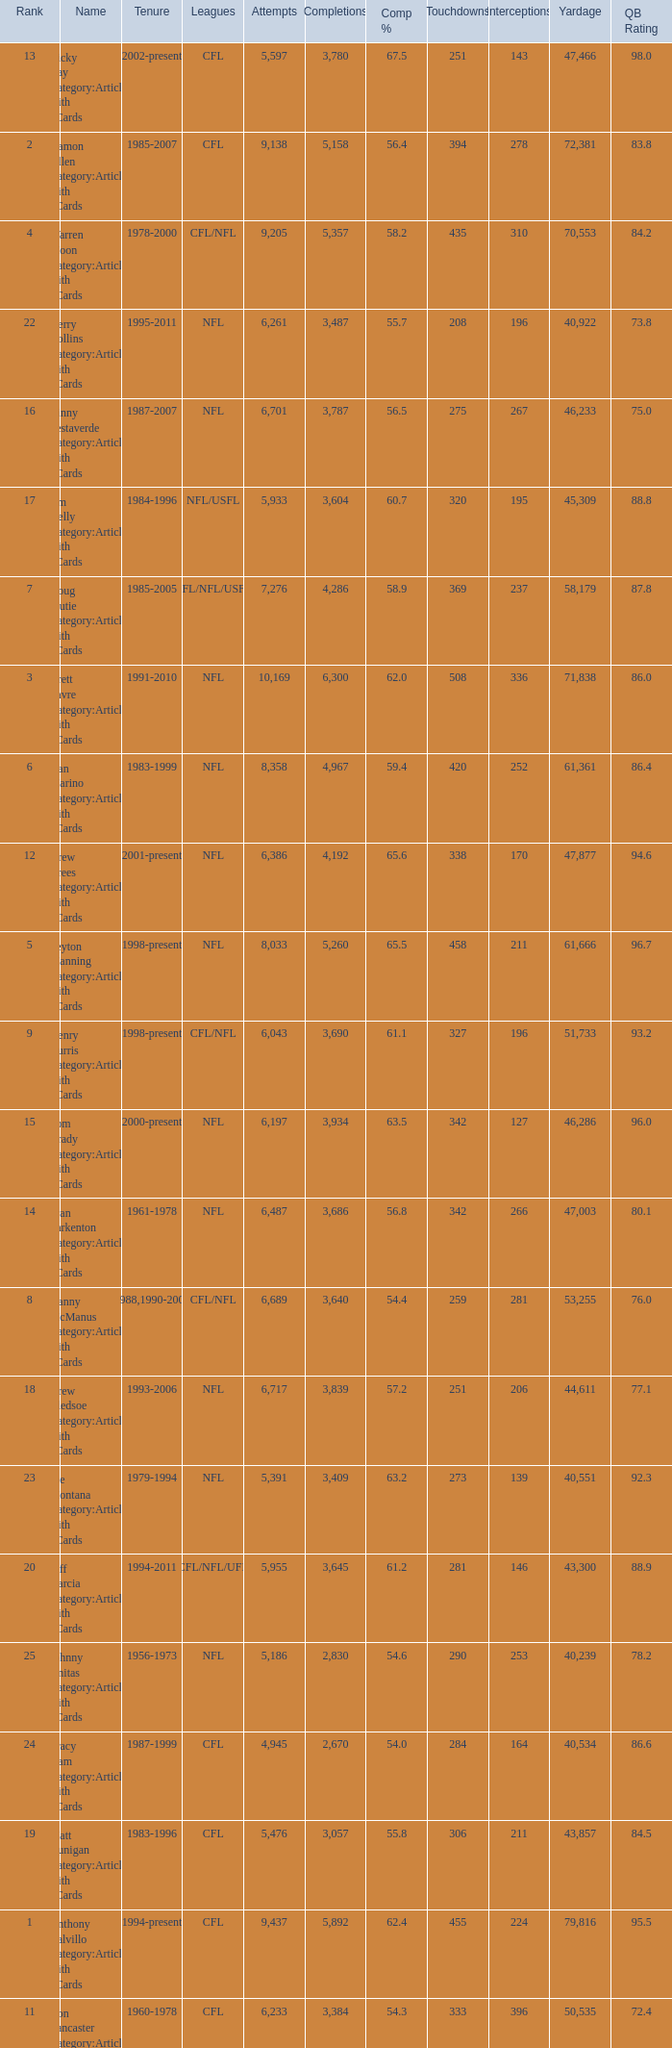What is the number of interceptions with less than 3,487 completions , more than 40,551 yardage, and the comp % is 55.8? 211.0. 